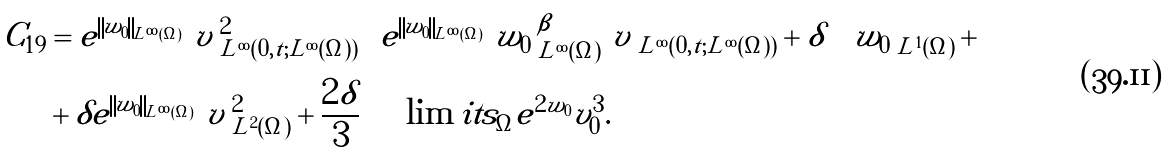<formula> <loc_0><loc_0><loc_500><loc_500>C _ { 1 9 } & = e ^ { \left \| w _ { 0 } \right \| _ { L ^ { \infty } ( \Omega ) } } \left \| v \right \| _ { L ^ { \infty } ( 0 , t ; L ^ { \infty } ( \Omega ) ) } ^ { 2 } \left [ e ^ { \left \| w _ { 0 } \right \| _ { L ^ { \infty } ( \Omega ) } } \left \| w _ { 0 } \right \| _ { L ^ { \infty } ( \Omega ) } ^ { \beta } \left \| v \right \| _ { L ^ { \infty } ( 0 , t ; L ^ { \infty } ( \Omega ) ) } + \delta \right ] \left \| w _ { 0 } \right \| _ { L ^ { 1 } ( \Omega ) } + \\ & + \delta e ^ { \left \| w _ { 0 } \right \| _ { L ^ { \infty } ( \Omega ) } } \left \| v \right \| _ { L ^ { 2 } ( \Omega ) } ^ { 2 } + \frac { 2 \delta } { 3 } \int \lim i t s _ { \Omega } e ^ { 2 w _ { 0 } } v _ { 0 } ^ { 3 } .</formula> 